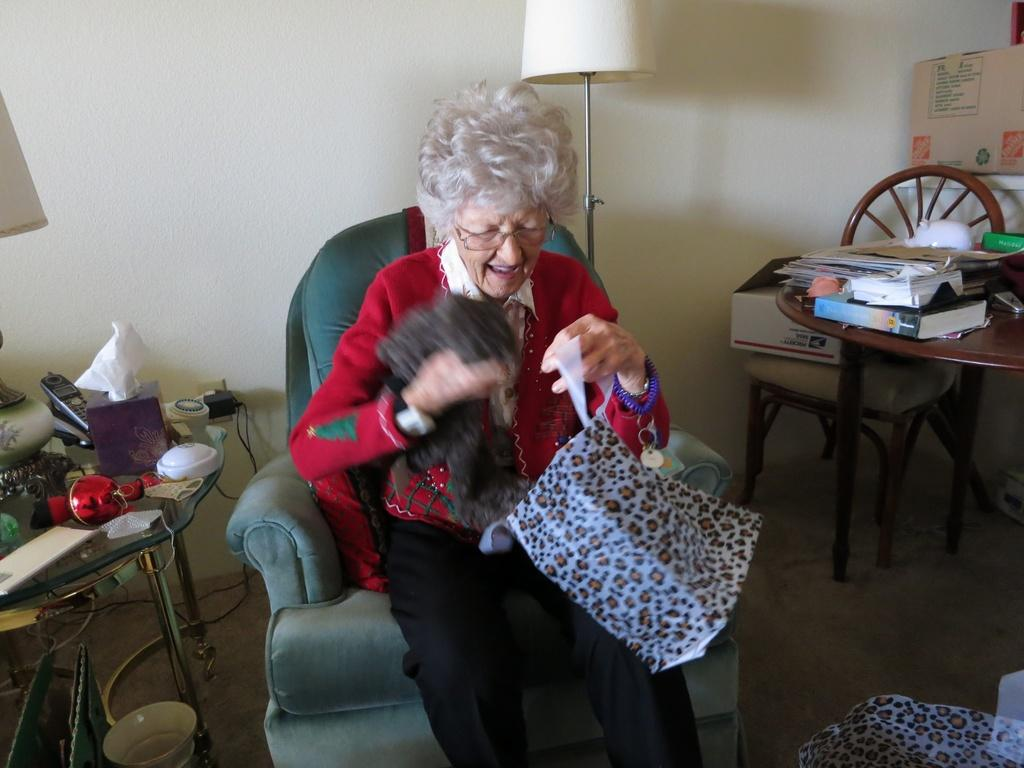What is the old woman doing in the image? The old woman is sitting in a chair. What is the old woman holding in the image? The old woman is holding a cloth. Where is the cloth located when not being held by the old woman? The cloth is in a bag. What can be found on the table beside the old woman? There are articles on a table beside the old woman. What is located behind the old woman in the image? There is a lamp behind the old woman. How does the old woman cry while holding the cloth in the image? There is no indication in the image that the old woman is crying or holding the cloth in a way that suggests crying. 